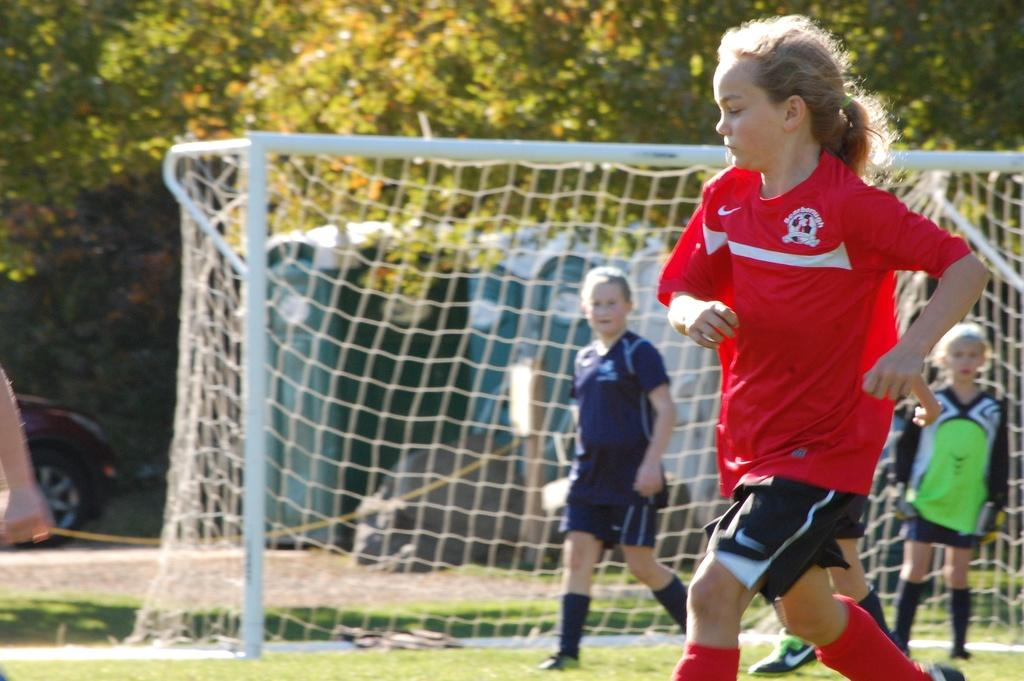How many girls are present in the image? There are many girls in the image. What type of clothing are the girls wearing? The girls are wearing jerseys and shorts. Where are the girls walking in the image? The girls are walking on a grass field. What can be seen in the background of the image? There is a goal post and trees visible in the background. What type of pickle is being used to score goals in the image? There is no pickle present in the image, and goals are not being scored with a pickle. 